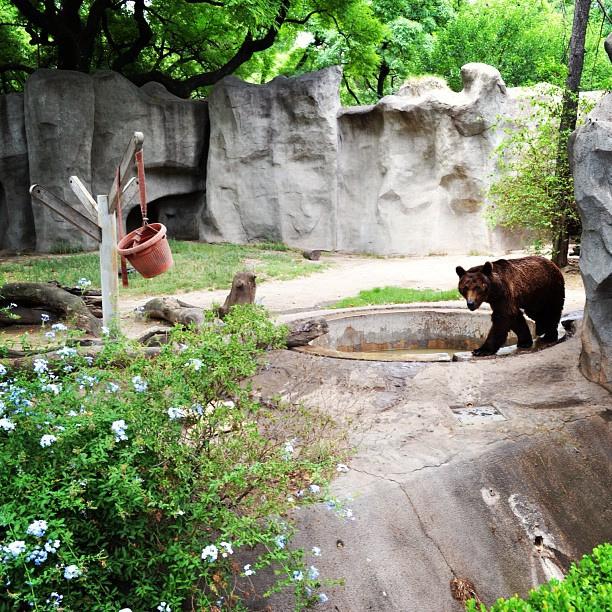Is there water in the pool by the bear?
Concise answer only. No. What toys does the bear have?
Short answer required. None. What animal is in the picture?
Short answer required. Bear. 